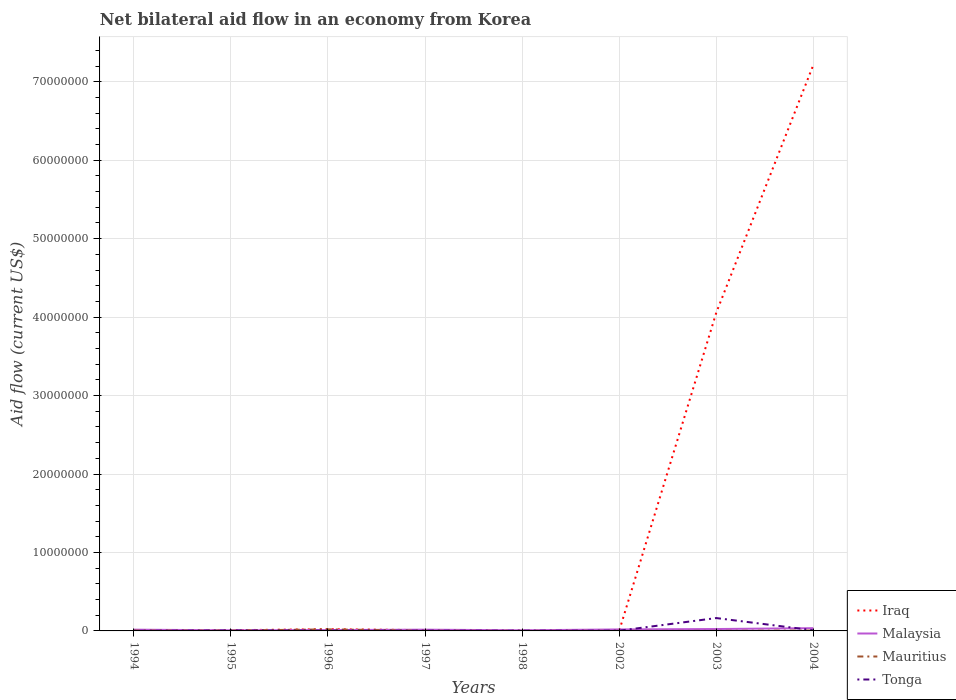How many different coloured lines are there?
Make the answer very short. 4. Does the line corresponding to Mauritius intersect with the line corresponding to Malaysia?
Offer a terse response. Yes. Is the number of lines equal to the number of legend labels?
Keep it short and to the point. Yes. Across all years, what is the maximum net bilateral aid flow in Iraq?
Your answer should be compact. 10000. What is the total net bilateral aid flow in Mauritius in the graph?
Keep it short and to the point. 1.50e+05. What is the difference between the highest and the second highest net bilateral aid flow in Iraq?
Ensure brevity in your answer.  7.21e+07. What is the difference between the highest and the lowest net bilateral aid flow in Iraq?
Your answer should be compact. 2. Is the net bilateral aid flow in Malaysia strictly greater than the net bilateral aid flow in Iraq over the years?
Ensure brevity in your answer.  No. How many years are there in the graph?
Provide a short and direct response. 8. Does the graph contain grids?
Provide a succinct answer. Yes. How many legend labels are there?
Make the answer very short. 4. What is the title of the graph?
Offer a terse response. Net bilateral aid flow in an economy from Korea. What is the label or title of the X-axis?
Your answer should be very brief. Years. What is the Aid flow (current US$) in Malaysia in 1994?
Your response must be concise. 1.60e+05. What is the Aid flow (current US$) in Mauritius in 1994?
Keep it short and to the point. 4.00e+04. What is the Aid flow (current US$) in Tonga in 1994?
Keep it short and to the point. 10000. What is the Aid flow (current US$) in Iraq in 1995?
Provide a short and direct response. 9.00e+04. What is the Aid flow (current US$) of Malaysia in 1995?
Provide a succinct answer. 8.00e+04. What is the Aid flow (current US$) in Mauritius in 1996?
Your response must be concise. 2.00e+05. What is the Aid flow (current US$) in Tonga in 1996?
Make the answer very short. 4.00e+04. What is the Aid flow (current US$) in Iraq in 1997?
Offer a terse response. 1.00e+05. What is the Aid flow (current US$) of Malaysia in 1997?
Provide a short and direct response. 1.60e+05. What is the Aid flow (current US$) of Tonga in 1997?
Your response must be concise. 3.00e+04. What is the Aid flow (current US$) of Mauritius in 1998?
Offer a terse response. 10000. What is the Aid flow (current US$) of Tonga in 1998?
Offer a terse response. 3.00e+04. What is the Aid flow (current US$) of Iraq in 2002?
Ensure brevity in your answer.  10000. What is the Aid flow (current US$) in Mauritius in 2002?
Provide a succinct answer. 10000. What is the Aid flow (current US$) in Tonga in 2002?
Your answer should be very brief. 3.00e+04. What is the Aid flow (current US$) in Iraq in 2003?
Ensure brevity in your answer.  4.06e+07. What is the Aid flow (current US$) in Tonga in 2003?
Make the answer very short. 1.64e+06. What is the Aid flow (current US$) of Iraq in 2004?
Provide a short and direct response. 7.22e+07. What is the Aid flow (current US$) of Malaysia in 2004?
Keep it short and to the point. 3.50e+05. What is the Aid flow (current US$) of Tonga in 2004?
Your answer should be very brief. 8.00e+04. Across all years, what is the maximum Aid flow (current US$) of Iraq?
Ensure brevity in your answer.  7.22e+07. Across all years, what is the maximum Aid flow (current US$) of Malaysia?
Give a very brief answer. 3.50e+05. Across all years, what is the maximum Aid flow (current US$) of Tonga?
Offer a terse response. 1.64e+06. Across all years, what is the minimum Aid flow (current US$) of Iraq?
Provide a succinct answer. 10000. Across all years, what is the minimum Aid flow (current US$) of Tonga?
Your answer should be very brief. 10000. What is the total Aid flow (current US$) in Iraq in the graph?
Keep it short and to the point. 1.13e+08. What is the total Aid flow (current US$) in Malaysia in the graph?
Keep it short and to the point. 1.37e+06. What is the total Aid flow (current US$) of Mauritius in the graph?
Offer a very short reply. 3.80e+05. What is the total Aid flow (current US$) of Tonga in the graph?
Make the answer very short. 1.92e+06. What is the difference between the Aid flow (current US$) of Malaysia in 1994 and that in 1995?
Your answer should be compact. 8.00e+04. What is the difference between the Aid flow (current US$) of Mauritius in 1994 and that in 1995?
Your answer should be compact. 0. What is the difference between the Aid flow (current US$) of Mauritius in 1994 and that in 1996?
Offer a very short reply. -1.60e+05. What is the difference between the Aid flow (current US$) in Tonga in 1994 and that in 1996?
Offer a very short reply. -3.00e+04. What is the difference between the Aid flow (current US$) in Iraq in 1994 and that in 1998?
Offer a terse response. 0. What is the difference between the Aid flow (current US$) in Malaysia in 1994 and that in 1998?
Give a very brief answer. 8.00e+04. What is the difference between the Aid flow (current US$) in Mauritius in 1994 and that in 1998?
Give a very brief answer. 3.00e+04. What is the difference between the Aid flow (current US$) in Mauritius in 1994 and that in 2002?
Make the answer very short. 3.00e+04. What is the difference between the Aid flow (current US$) in Tonga in 1994 and that in 2002?
Offer a terse response. -2.00e+04. What is the difference between the Aid flow (current US$) in Iraq in 1994 and that in 2003?
Ensure brevity in your answer.  -4.06e+07. What is the difference between the Aid flow (current US$) in Malaysia in 1994 and that in 2003?
Provide a succinct answer. -8.00e+04. What is the difference between the Aid flow (current US$) of Tonga in 1994 and that in 2003?
Ensure brevity in your answer.  -1.63e+06. What is the difference between the Aid flow (current US$) of Iraq in 1994 and that in 2004?
Keep it short and to the point. -7.21e+07. What is the difference between the Aid flow (current US$) in Malaysia in 1994 and that in 2004?
Offer a terse response. -1.90e+05. What is the difference between the Aid flow (current US$) of Mauritius in 1995 and that in 1996?
Provide a short and direct response. -1.60e+05. What is the difference between the Aid flow (current US$) in Tonga in 1995 and that in 1996?
Keep it short and to the point. 2.00e+04. What is the difference between the Aid flow (current US$) in Malaysia in 1995 and that in 1997?
Keep it short and to the point. -8.00e+04. What is the difference between the Aid flow (current US$) in Mauritius in 1995 and that in 1998?
Offer a terse response. 3.00e+04. What is the difference between the Aid flow (current US$) in Malaysia in 1995 and that in 2002?
Offer a terse response. -1.10e+05. What is the difference between the Aid flow (current US$) of Tonga in 1995 and that in 2002?
Give a very brief answer. 3.00e+04. What is the difference between the Aid flow (current US$) in Iraq in 1995 and that in 2003?
Provide a succinct answer. -4.05e+07. What is the difference between the Aid flow (current US$) of Tonga in 1995 and that in 2003?
Your answer should be compact. -1.58e+06. What is the difference between the Aid flow (current US$) in Iraq in 1995 and that in 2004?
Your answer should be very brief. -7.21e+07. What is the difference between the Aid flow (current US$) in Malaysia in 1995 and that in 2004?
Ensure brevity in your answer.  -2.70e+05. What is the difference between the Aid flow (current US$) in Iraq in 1996 and that in 1997?
Your response must be concise. 1.20e+05. What is the difference between the Aid flow (current US$) of Malaysia in 1996 and that in 1997?
Offer a very short reply. -5.00e+04. What is the difference between the Aid flow (current US$) in Tonga in 1996 and that in 1997?
Ensure brevity in your answer.  10000. What is the difference between the Aid flow (current US$) in Mauritius in 1996 and that in 1998?
Give a very brief answer. 1.90e+05. What is the difference between the Aid flow (current US$) in Iraq in 1996 and that in 2002?
Your answer should be very brief. 2.10e+05. What is the difference between the Aid flow (current US$) in Mauritius in 1996 and that in 2002?
Your response must be concise. 1.90e+05. What is the difference between the Aid flow (current US$) in Iraq in 1996 and that in 2003?
Provide a succinct answer. -4.04e+07. What is the difference between the Aid flow (current US$) of Mauritius in 1996 and that in 2003?
Your answer should be very brief. 1.90e+05. What is the difference between the Aid flow (current US$) of Tonga in 1996 and that in 2003?
Give a very brief answer. -1.60e+06. What is the difference between the Aid flow (current US$) of Iraq in 1996 and that in 2004?
Keep it short and to the point. -7.19e+07. What is the difference between the Aid flow (current US$) of Iraq in 1997 and that in 1998?
Ensure brevity in your answer.  8.00e+04. What is the difference between the Aid flow (current US$) of Malaysia in 1997 and that in 1998?
Offer a terse response. 8.00e+04. What is the difference between the Aid flow (current US$) in Mauritius in 1997 and that in 1998?
Provide a succinct answer. 10000. What is the difference between the Aid flow (current US$) of Tonga in 1997 and that in 1998?
Keep it short and to the point. 0. What is the difference between the Aid flow (current US$) in Iraq in 1997 and that in 2002?
Ensure brevity in your answer.  9.00e+04. What is the difference between the Aid flow (current US$) of Malaysia in 1997 and that in 2002?
Provide a short and direct response. -3.00e+04. What is the difference between the Aid flow (current US$) in Mauritius in 1997 and that in 2002?
Make the answer very short. 10000. What is the difference between the Aid flow (current US$) of Tonga in 1997 and that in 2002?
Your answer should be very brief. 0. What is the difference between the Aid flow (current US$) of Iraq in 1997 and that in 2003?
Provide a succinct answer. -4.05e+07. What is the difference between the Aid flow (current US$) in Mauritius in 1997 and that in 2003?
Make the answer very short. 10000. What is the difference between the Aid flow (current US$) in Tonga in 1997 and that in 2003?
Keep it short and to the point. -1.61e+06. What is the difference between the Aid flow (current US$) in Iraq in 1997 and that in 2004?
Provide a short and direct response. -7.20e+07. What is the difference between the Aid flow (current US$) of Malaysia in 1997 and that in 2004?
Give a very brief answer. -1.90e+05. What is the difference between the Aid flow (current US$) of Malaysia in 1998 and that in 2002?
Provide a succinct answer. -1.10e+05. What is the difference between the Aid flow (current US$) of Iraq in 1998 and that in 2003?
Keep it short and to the point. -4.06e+07. What is the difference between the Aid flow (current US$) of Tonga in 1998 and that in 2003?
Your answer should be compact. -1.61e+06. What is the difference between the Aid flow (current US$) of Iraq in 1998 and that in 2004?
Offer a very short reply. -7.21e+07. What is the difference between the Aid flow (current US$) of Malaysia in 1998 and that in 2004?
Ensure brevity in your answer.  -2.70e+05. What is the difference between the Aid flow (current US$) in Iraq in 2002 and that in 2003?
Offer a terse response. -4.06e+07. What is the difference between the Aid flow (current US$) in Malaysia in 2002 and that in 2003?
Ensure brevity in your answer.  -5.00e+04. What is the difference between the Aid flow (current US$) of Mauritius in 2002 and that in 2003?
Offer a very short reply. 0. What is the difference between the Aid flow (current US$) of Tonga in 2002 and that in 2003?
Ensure brevity in your answer.  -1.61e+06. What is the difference between the Aid flow (current US$) in Iraq in 2002 and that in 2004?
Keep it short and to the point. -7.21e+07. What is the difference between the Aid flow (current US$) in Mauritius in 2002 and that in 2004?
Provide a short and direct response. -4.00e+04. What is the difference between the Aid flow (current US$) in Tonga in 2002 and that in 2004?
Give a very brief answer. -5.00e+04. What is the difference between the Aid flow (current US$) of Iraq in 2003 and that in 2004?
Ensure brevity in your answer.  -3.16e+07. What is the difference between the Aid flow (current US$) of Tonga in 2003 and that in 2004?
Offer a terse response. 1.56e+06. What is the difference between the Aid flow (current US$) of Iraq in 1994 and the Aid flow (current US$) of Malaysia in 1995?
Provide a succinct answer. -6.00e+04. What is the difference between the Aid flow (current US$) in Iraq in 1994 and the Aid flow (current US$) in Mauritius in 1995?
Give a very brief answer. -2.00e+04. What is the difference between the Aid flow (current US$) of Malaysia in 1994 and the Aid flow (current US$) of Mauritius in 1995?
Offer a terse response. 1.20e+05. What is the difference between the Aid flow (current US$) of Malaysia in 1994 and the Aid flow (current US$) of Tonga in 1995?
Make the answer very short. 1.00e+05. What is the difference between the Aid flow (current US$) of Mauritius in 1994 and the Aid flow (current US$) of Tonga in 1995?
Your answer should be very brief. -2.00e+04. What is the difference between the Aid flow (current US$) in Iraq in 1994 and the Aid flow (current US$) in Malaysia in 1996?
Give a very brief answer. -9.00e+04. What is the difference between the Aid flow (current US$) in Iraq in 1994 and the Aid flow (current US$) in Mauritius in 1996?
Give a very brief answer. -1.80e+05. What is the difference between the Aid flow (current US$) of Malaysia in 1994 and the Aid flow (current US$) of Mauritius in 1996?
Your answer should be compact. -4.00e+04. What is the difference between the Aid flow (current US$) of Mauritius in 1994 and the Aid flow (current US$) of Tonga in 1996?
Make the answer very short. 0. What is the difference between the Aid flow (current US$) of Iraq in 1994 and the Aid flow (current US$) of Mauritius in 1997?
Provide a succinct answer. 0. What is the difference between the Aid flow (current US$) in Iraq in 1994 and the Aid flow (current US$) in Tonga in 1997?
Your answer should be very brief. -10000. What is the difference between the Aid flow (current US$) of Malaysia in 1994 and the Aid flow (current US$) of Mauritius in 1997?
Provide a succinct answer. 1.40e+05. What is the difference between the Aid flow (current US$) of Malaysia in 1994 and the Aid flow (current US$) of Tonga in 1997?
Provide a short and direct response. 1.30e+05. What is the difference between the Aid flow (current US$) in Mauritius in 1994 and the Aid flow (current US$) in Tonga in 1997?
Your answer should be compact. 10000. What is the difference between the Aid flow (current US$) of Iraq in 1994 and the Aid flow (current US$) of Tonga in 1998?
Provide a short and direct response. -10000. What is the difference between the Aid flow (current US$) in Malaysia in 1994 and the Aid flow (current US$) in Mauritius in 1998?
Provide a succinct answer. 1.50e+05. What is the difference between the Aid flow (current US$) in Iraq in 1994 and the Aid flow (current US$) in Malaysia in 2002?
Ensure brevity in your answer.  -1.70e+05. What is the difference between the Aid flow (current US$) in Iraq in 1994 and the Aid flow (current US$) in Mauritius in 2002?
Offer a terse response. 10000. What is the difference between the Aid flow (current US$) in Mauritius in 1994 and the Aid flow (current US$) in Tonga in 2002?
Offer a terse response. 10000. What is the difference between the Aid flow (current US$) in Iraq in 1994 and the Aid flow (current US$) in Malaysia in 2003?
Your response must be concise. -2.20e+05. What is the difference between the Aid flow (current US$) of Iraq in 1994 and the Aid flow (current US$) of Mauritius in 2003?
Your response must be concise. 10000. What is the difference between the Aid flow (current US$) in Iraq in 1994 and the Aid flow (current US$) in Tonga in 2003?
Provide a succinct answer. -1.62e+06. What is the difference between the Aid flow (current US$) in Malaysia in 1994 and the Aid flow (current US$) in Mauritius in 2003?
Your response must be concise. 1.50e+05. What is the difference between the Aid flow (current US$) in Malaysia in 1994 and the Aid flow (current US$) in Tonga in 2003?
Offer a very short reply. -1.48e+06. What is the difference between the Aid flow (current US$) of Mauritius in 1994 and the Aid flow (current US$) of Tonga in 2003?
Give a very brief answer. -1.60e+06. What is the difference between the Aid flow (current US$) in Iraq in 1994 and the Aid flow (current US$) in Malaysia in 2004?
Offer a very short reply. -3.30e+05. What is the difference between the Aid flow (current US$) of Iraq in 1994 and the Aid flow (current US$) of Tonga in 2004?
Offer a very short reply. -6.00e+04. What is the difference between the Aid flow (current US$) of Malaysia in 1994 and the Aid flow (current US$) of Tonga in 2004?
Offer a terse response. 8.00e+04. What is the difference between the Aid flow (current US$) in Mauritius in 1994 and the Aid flow (current US$) in Tonga in 2004?
Offer a very short reply. -4.00e+04. What is the difference between the Aid flow (current US$) of Iraq in 1995 and the Aid flow (current US$) of Tonga in 1996?
Give a very brief answer. 5.00e+04. What is the difference between the Aid flow (current US$) in Iraq in 1995 and the Aid flow (current US$) in Tonga in 1997?
Keep it short and to the point. 6.00e+04. What is the difference between the Aid flow (current US$) in Malaysia in 1995 and the Aid flow (current US$) in Mauritius in 1997?
Provide a succinct answer. 6.00e+04. What is the difference between the Aid flow (current US$) of Malaysia in 1995 and the Aid flow (current US$) of Tonga in 1997?
Provide a short and direct response. 5.00e+04. What is the difference between the Aid flow (current US$) in Mauritius in 1995 and the Aid flow (current US$) in Tonga in 1997?
Offer a terse response. 10000. What is the difference between the Aid flow (current US$) of Iraq in 1995 and the Aid flow (current US$) of Malaysia in 1998?
Ensure brevity in your answer.  10000. What is the difference between the Aid flow (current US$) in Iraq in 1995 and the Aid flow (current US$) in Mauritius in 1998?
Your response must be concise. 8.00e+04. What is the difference between the Aid flow (current US$) of Iraq in 1995 and the Aid flow (current US$) of Tonga in 1998?
Make the answer very short. 6.00e+04. What is the difference between the Aid flow (current US$) of Malaysia in 1995 and the Aid flow (current US$) of Mauritius in 1998?
Provide a short and direct response. 7.00e+04. What is the difference between the Aid flow (current US$) in Iraq in 1995 and the Aid flow (current US$) in Malaysia in 2002?
Give a very brief answer. -1.00e+05. What is the difference between the Aid flow (current US$) of Iraq in 1995 and the Aid flow (current US$) of Mauritius in 2002?
Your answer should be compact. 8.00e+04. What is the difference between the Aid flow (current US$) of Iraq in 1995 and the Aid flow (current US$) of Tonga in 2002?
Provide a short and direct response. 6.00e+04. What is the difference between the Aid flow (current US$) of Iraq in 1995 and the Aid flow (current US$) of Malaysia in 2003?
Provide a short and direct response. -1.50e+05. What is the difference between the Aid flow (current US$) in Iraq in 1995 and the Aid flow (current US$) in Tonga in 2003?
Your answer should be compact. -1.55e+06. What is the difference between the Aid flow (current US$) in Malaysia in 1995 and the Aid flow (current US$) in Mauritius in 2003?
Ensure brevity in your answer.  7.00e+04. What is the difference between the Aid flow (current US$) in Malaysia in 1995 and the Aid flow (current US$) in Tonga in 2003?
Your answer should be compact. -1.56e+06. What is the difference between the Aid flow (current US$) in Mauritius in 1995 and the Aid flow (current US$) in Tonga in 2003?
Ensure brevity in your answer.  -1.60e+06. What is the difference between the Aid flow (current US$) in Iraq in 1995 and the Aid flow (current US$) in Malaysia in 2004?
Offer a terse response. -2.60e+05. What is the difference between the Aid flow (current US$) of Malaysia in 1995 and the Aid flow (current US$) of Tonga in 2004?
Your answer should be very brief. 0. What is the difference between the Aid flow (current US$) in Mauritius in 1995 and the Aid flow (current US$) in Tonga in 2004?
Offer a very short reply. -4.00e+04. What is the difference between the Aid flow (current US$) of Iraq in 1996 and the Aid flow (current US$) of Tonga in 1997?
Provide a short and direct response. 1.90e+05. What is the difference between the Aid flow (current US$) of Malaysia in 1996 and the Aid flow (current US$) of Mauritius in 1997?
Offer a very short reply. 9.00e+04. What is the difference between the Aid flow (current US$) in Malaysia in 1996 and the Aid flow (current US$) in Tonga in 1997?
Your answer should be very brief. 8.00e+04. What is the difference between the Aid flow (current US$) of Mauritius in 1996 and the Aid flow (current US$) of Tonga in 1997?
Offer a very short reply. 1.70e+05. What is the difference between the Aid flow (current US$) in Iraq in 1996 and the Aid flow (current US$) in Mauritius in 1998?
Ensure brevity in your answer.  2.10e+05. What is the difference between the Aid flow (current US$) of Iraq in 1996 and the Aid flow (current US$) of Tonga in 1998?
Your response must be concise. 1.90e+05. What is the difference between the Aid flow (current US$) in Malaysia in 1996 and the Aid flow (current US$) in Mauritius in 1998?
Offer a terse response. 1.00e+05. What is the difference between the Aid flow (current US$) in Iraq in 1996 and the Aid flow (current US$) in Malaysia in 2002?
Provide a short and direct response. 3.00e+04. What is the difference between the Aid flow (current US$) in Iraq in 1996 and the Aid flow (current US$) in Mauritius in 2002?
Make the answer very short. 2.10e+05. What is the difference between the Aid flow (current US$) of Malaysia in 1996 and the Aid flow (current US$) of Mauritius in 2002?
Ensure brevity in your answer.  1.00e+05. What is the difference between the Aid flow (current US$) in Iraq in 1996 and the Aid flow (current US$) in Malaysia in 2003?
Your answer should be compact. -2.00e+04. What is the difference between the Aid flow (current US$) in Iraq in 1996 and the Aid flow (current US$) in Tonga in 2003?
Keep it short and to the point. -1.42e+06. What is the difference between the Aid flow (current US$) of Malaysia in 1996 and the Aid flow (current US$) of Tonga in 2003?
Make the answer very short. -1.53e+06. What is the difference between the Aid flow (current US$) of Mauritius in 1996 and the Aid flow (current US$) of Tonga in 2003?
Your response must be concise. -1.44e+06. What is the difference between the Aid flow (current US$) in Iraq in 1996 and the Aid flow (current US$) in Malaysia in 2004?
Offer a terse response. -1.30e+05. What is the difference between the Aid flow (current US$) in Iraq in 1996 and the Aid flow (current US$) in Mauritius in 2004?
Provide a succinct answer. 1.70e+05. What is the difference between the Aid flow (current US$) of Iraq in 1997 and the Aid flow (current US$) of Tonga in 1998?
Your response must be concise. 7.00e+04. What is the difference between the Aid flow (current US$) in Mauritius in 1997 and the Aid flow (current US$) in Tonga in 1998?
Provide a succinct answer. -10000. What is the difference between the Aid flow (current US$) of Iraq in 1997 and the Aid flow (current US$) of Malaysia in 2002?
Provide a short and direct response. -9.00e+04. What is the difference between the Aid flow (current US$) of Malaysia in 1997 and the Aid flow (current US$) of Mauritius in 2002?
Your answer should be very brief. 1.50e+05. What is the difference between the Aid flow (current US$) of Malaysia in 1997 and the Aid flow (current US$) of Tonga in 2002?
Provide a succinct answer. 1.30e+05. What is the difference between the Aid flow (current US$) of Iraq in 1997 and the Aid flow (current US$) of Malaysia in 2003?
Provide a succinct answer. -1.40e+05. What is the difference between the Aid flow (current US$) of Iraq in 1997 and the Aid flow (current US$) of Tonga in 2003?
Give a very brief answer. -1.54e+06. What is the difference between the Aid flow (current US$) of Malaysia in 1997 and the Aid flow (current US$) of Tonga in 2003?
Provide a succinct answer. -1.48e+06. What is the difference between the Aid flow (current US$) of Mauritius in 1997 and the Aid flow (current US$) of Tonga in 2003?
Offer a terse response. -1.62e+06. What is the difference between the Aid flow (current US$) in Iraq in 1997 and the Aid flow (current US$) in Malaysia in 2004?
Your answer should be very brief. -2.50e+05. What is the difference between the Aid flow (current US$) of Iraq in 1997 and the Aid flow (current US$) of Tonga in 2004?
Offer a terse response. 2.00e+04. What is the difference between the Aid flow (current US$) in Malaysia in 1997 and the Aid flow (current US$) in Mauritius in 2004?
Ensure brevity in your answer.  1.10e+05. What is the difference between the Aid flow (current US$) in Iraq in 1998 and the Aid flow (current US$) in Malaysia in 2002?
Give a very brief answer. -1.70e+05. What is the difference between the Aid flow (current US$) in Iraq in 1998 and the Aid flow (current US$) in Malaysia in 2003?
Keep it short and to the point. -2.20e+05. What is the difference between the Aid flow (current US$) in Iraq in 1998 and the Aid flow (current US$) in Mauritius in 2003?
Your answer should be compact. 10000. What is the difference between the Aid flow (current US$) of Iraq in 1998 and the Aid flow (current US$) of Tonga in 2003?
Give a very brief answer. -1.62e+06. What is the difference between the Aid flow (current US$) in Malaysia in 1998 and the Aid flow (current US$) in Tonga in 2003?
Make the answer very short. -1.56e+06. What is the difference between the Aid flow (current US$) in Mauritius in 1998 and the Aid flow (current US$) in Tonga in 2003?
Provide a succinct answer. -1.63e+06. What is the difference between the Aid flow (current US$) in Iraq in 1998 and the Aid flow (current US$) in Malaysia in 2004?
Offer a very short reply. -3.30e+05. What is the difference between the Aid flow (current US$) in Iraq in 1998 and the Aid flow (current US$) in Mauritius in 2004?
Provide a short and direct response. -3.00e+04. What is the difference between the Aid flow (current US$) of Iraq in 1998 and the Aid flow (current US$) of Tonga in 2004?
Keep it short and to the point. -6.00e+04. What is the difference between the Aid flow (current US$) of Malaysia in 1998 and the Aid flow (current US$) of Mauritius in 2004?
Your answer should be very brief. 3.00e+04. What is the difference between the Aid flow (current US$) in Iraq in 2002 and the Aid flow (current US$) in Malaysia in 2003?
Your response must be concise. -2.30e+05. What is the difference between the Aid flow (current US$) in Iraq in 2002 and the Aid flow (current US$) in Tonga in 2003?
Your answer should be very brief. -1.63e+06. What is the difference between the Aid flow (current US$) of Malaysia in 2002 and the Aid flow (current US$) of Mauritius in 2003?
Make the answer very short. 1.80e+05. What is the difference between the Aid flow (current US$) in Malaysia in 2002 and the Aid flow (current US$) in Tonga in 2003?
Your answer should be compact. -1.45e+06. What is the difference between the Aid flow (current US$) of Mauritius in 2002 and the Aid flow (current US$) of Tonga in 2003?
Ensure brevity in your answer.  -1.63e+06. What is the difference between the Aid flow (current US$) of Malaysia in 2002 and the Aid flow (current US$) of Mauritius in 2004?
Give a very brief answer. 1.40e+05. What is the difference between the Aid flow (current US$) in Malaysia in 2002 and the Aid flow (current US$) in Tonga in 2004?
Give a very brief answer. 1.10e+05. What is the difference between the Aid flow (current US$) of Mauritius in 2002 and the Aid flow (current US$) of Tonga in 2004?
Give a very brief answer. -7.00e+04. What is the difference between the Aid flow (current US$) of Iraq in 2003 and the Aid flow (current US$) of Malaysia in 2004?
Ensure brevity in your answer.  4.02e+07. What is the difference between the Aid flow (current US$) in Iraq in 2003 and the Aid flow (current US$) in Mauritius in 2004?
Provide a succinct answer. 4.05e+07. What is the difference between the Aid flow (current US$) in Iraq in 2003 and the Aid flow (current US$) in Tonga in 2004?
Make the answer very short. 4.05e+07. What is the difference between the Aid flow (current US$) of Malaysia in 2003 and the Aid flow (current US$) of Mauritius in 2004?
Provide a succinct answer. 1.90e+05. What is the average Aid flow (current US$) of Iraq per year?
Give a very brief answer. 1.41e+07. What is the average Aid flow (current US$) of Malaysia per year?
Keep it short and to the point. 1.71e+05. What is the average Aid flow (current US$) in Mauritius per year?
Your answer should be very brief. 4.75e+04. In the year 1994, what is the difference between the Aid flow (current US$) in Iraq and Aid flow (current US$) in Mauritius?
Ensure brevity in your answer.  -2.00e+04. In the year 1994, what is the difference between the Aid flow (current US$) in Iraq and Aid flow (current US$) in Tonga?
Provide a short and direct response. 10000. In the year 1994, what is the difference between the Aid flow (current US$) of Mauritius and Aid flow (current US$) of Tonga?
Your answer should be very brief. 3.00e+04. In the year 1995, what is the difference between the Aid flow (current US$) of Iraq and Aid flow (current US$) of Mauritius?
Your answer should be compact. 5.00e+04. In the year 1995, what is the difference between the Aid flow (current US$) in Malaysia and Aid flow (current US$) in Mauritius?
Your answer should be very brief. 4.00e+04. In the year 1996, what is the difference between the Aid flow (current US$) in Iraq and Aid flow (current US$) in Malaysia?
Offer a very short reply. 1.10e+05. In the year 1996, what is the difference between the Aid flow (current US$) of Iraq and Aid flow (current US$) of Mauritius?
Offer a very short reply. 2.00e+04. In the year 1996, what is the difference between the Aid flow (current US$) in Iraq and Aid flow (current US$) in Tonga?
Your response must be concise. 1.80e+05. In the year 1996, what is the difference between the Aid flow (current US$) in Malaysia and Aid flow (current US$) in Mauritius?
Your answer should be compact. -9.00e+04. In the year 1996, what is the difference between the Aid flow (current US$) of Mauritius and Aid flow (current US$) of Tonga?
Your response must be concise. 1.60e+05. In the year 1997, what is the difference between the Aid flow (current US$) of Iraq and Aid flow (current US$) of Malaysia?
Give a very brief answer. -6.00e+04. In the year 1997, what is the difference between the Aid flow (current US$) in Iraq and Aid flow (current US$) in Mauritius?
Make the answer very short. 8.00e+04. In the year 1998, what is the difference between the Aid flow (current US$) in Iraq and Aid flow (current US$) in Mauritius?
Make the answer very short. 10000. In the year 1998, what is the difference between the Aid flow (current US$) of Iraq and Aid flow (current US$) of Tonga?
Offer a terse response. -10000. In the year 1998, what is the difference between the Aid flow (current US$) in Malaysia and Aid flow (current US$) in Mauritius?
Provide a succinct answer. 7.00e+04. In the year 1998, what is the difference between the Aid flow (current US$) of Mauritius and Aid flow (current US$) of Tonga?
Ensure brevity in your answer.  -2.00e+04. In the year 2002, what is the difference between the Aid flow (current US$) in Iraq and Aid flow (current US$) in Malaysia?
Offer a very short reply. -1.80e+05. In the year 2002, what is the difference between the Aid flow (current US$) in Iraq and Aid flow (current US$) in Mauritius?
Your answer should be very brief. 0. In the year 2002, what is the difference between the Aid flow (current US$) in Malaysia and Aid flow (current US$) in Tonga?
Give a very brief answer. 1.60e+05. In the year 2003, what is the difference between the Aid flow (current US$) of Iraq and Aid flow (current US$) of Malaysia?
Your answer should be very brief. 4.03e+07. In the year 2003, what is the difference between the Aid flow (current US$) in Iraq and Aid flow (current US$) in Mauritius?
Provide a short and direct response. 4.06e+07. In the year 2003, what is the difference between the Aid flow (current US$) in Iraq and Aid flow (current US$) in Tonga?
Give a very brief answer. 3.89e+07. In the year 2003, what is the difference between the Aid flow (current US$) of Malaysia and Aid flow (current US$) of Tonga?
Keep it short and to the point. -1.40e+06. In the year 2003, what is the difference between the Aid flow (current US$) in Mauritius and Aid flow (current US$) in Tonga?
Keep it short and to the point. -1.63e+06. In the year 2004, what is the difference between the Aid flow (current US$) in Iraq and Aid flow (current US$) in Malaysia?
Make the answer very short. 7.18e+07. In the year 2004, what is the difference between the Aid flow (current US$) of Iraq and Aid flow (current US$) of Mauritius?
Offer a very short reply. 7.21e+07. In the year 2004, what is the difference between the Aid flow (current US$) of Iraq and Aid flow (current US$) of Tonga?
Provide a succinct answer. 7.21e+07. In the year 2004, what is the difference between the Aid flow (current US$) in Malaysia and Aid flow (current US$) in Tonga?
Provide a short and direct response. 2.70e+05. What is the ratio of the Aid flow (current US$) in Iraq in 1994 to that in 1995?
Give a very brief answer. 0.22. What is the ratio of the Aid flow (current US$) in Malaysia in 1994 to that in 1995?
Provide a succinct answer. 2. What is the ratio of the Aid flow (current US$) of Mauritius in 1994 to that in 1995?
Your answer should be very brief. 1. What is the ratio of the Aid flow (current US$) in Iraq in 1994 to that in 1996?
Your answer should be compact. 0.09. What is the ratio of the Aid flow (current US$) in Malaysia in 1994 to that in 1996?
Ensure brevity in your answer.  1.45. What is the ratio of the Aid flow (current US$) of Tonga in 1994 to that in 1996?
Give a very brief answer. 0.25. What is the ratio of the Aid flow (current US$) in Iraq in 1994 to that in 1997?
Provide a succinct answer. 0.2. What is the ratio of the Aid flow (current US$) in Mauritius in 1994 to that in 1997?
Your answer should be very brief. 2. What is the ratio of the Aid flow (current US$) of Tonga in 1994 to that in 1997?
Your response must be concise. 0.33. What is the ratio of the Aid flow (current US$) of Iraq in 1994 to that in 2002?
Keep it short and to the point. 2. What is the ratio of the Aid flow (current US$) in Malaysia in 1994 to that in 2002?
Offer a terse response. 0.84. What is the ratio of the Aid flow (current US$) in Iraq in 1994 to that in 2003?
Give a very brief answer. 0. What is the ratio of the Aid flow (current US$) in Tonga in 1994 to that in 2003?
Ensure brevity in your answer.  0.01. What is the ratio of the Aid flow (current US$) in Malaysia in 1994 to that in 2004?
Ensure brevity in your answer.  0.46. What is the ratio of the Aid flow (current US$) of Mauritius in 1994 to that in 2004?
Keep it short and to the point. 0.8. What is the ratio of the Aid flow (current US$) of Tonga in 1994 to that in 2004?
Offer a very short reply. 0.12. What is the ratio of the Aid flow (current US$) of Iraq in 1995 to that in 1996?
Your answer should be compact. 0.41. What is the ratio of the Aid flow (current US$) in Malaysia in 1995 to that in 1996?
Your answer should be compact. 0.73. What is the ratio of the Aid flow (current US$) of Iraq in 1995 to that in 1997?
Your answer should be very brief. 0.9. What is the ratio of the Aid flow (current US$) in Malaysia in 1995 to that in 1997?
Make the answer very short. 0.5. What is the ratio of the Aid flow (current US$) of Mauritius in 1995 to that in 1997?
Keep it short and to the point. 2. What is the ratio of the Aid flow (current US$) in Tonga in 1995 to that in 1997?
Keep it short and to the point. 2. What is the ratio of the Aid flow (current US$) in Malaysia in 1995 to that in 1998?
Offer a terse response. 1. What is the ratio of the Aid flow (current US$) of Mauritius in 1995 to that in 1998?
Make the answer very short. 4. What is the ratio of the Aid flow (current US$) of Malaysia in 1995 to that in 2002?
Provide a short and direct response. 0.42. What is the ratio of the Aid flow (current US$) of Iraq in 1995 to that in 2003?
Make the answer very short. 0. What is the ratio of the Aid flow (current US$) of Malaysia in 1995 to that in 2003?
Provide a succinct answer. 0.33. What is the ratio of the Aid flow (current US$) of Mauritius in 1995 to that in 2003?
Your answer should be very brief. 4. What is the ratio of the Aid flow (current US$) of Tonga in 1995 to that in 2003?
Your response must be concise. 0.04. What is the ratio of the Aid flow (current US$) of Iraq in 1995 to that in 2004?
Your answer should be very brief. 0. What is the ratio of the Aid flow (current US$) of Malaysia in 1995 to that in 2004?
Keep it short and to the point. 0.23. What is the ratio of the Aid flow (current US$) of Mauritius in 1995 to that in 2004?
Keep it short and to the point. 0.8. What is the ratio of the Aid flow (current US$) of Iraq in 1996 to that in 1997?
Provide a short and direct response. 2.2. What is the ratio of the Aid flow (current US$) in Malaysia in 1996 to that in 1997?
Provide a succinct answer. 0.69. What is the ratio of the Aid flow (current US$) in Tonga in 1996 to that in 1997?
Ensure brevity in your answer.  1.33. What is the ratio of the Aid flow (current US$) in Malaysia in 1996 to that in 1998?
Ensure brevity in your answer.  1.38. What is the ratio of the Aid flow (current US$) in Mauritius in 1996 to that in 1998?
Your answer should be compact. 20. What is the ratio of the Aid flow (current US$) of Tonga in 1996 to that in 1998?
Offer a very short reply. 1.33. What is the ratio of the Aid flow (current US$) in Iraq in 1996 to that in 2002?
Provide a short and direct response. 22. What is the ratio of the Aid flow (current US$) of Malaysia in 1996 to that in 2002?
Your response must be concise. 0.58. What is the ratio of the Aid flow (current US$) of Iraq in 1996 to that in 2003?
Your answer should be compact. 0.01. What is the ratio of the Aid flow (current US$) in Malaysia in 1996 to that in 2003?
Ensure brevity in your answer.  0.46. What is the ratio of the Aid flow (current US$) of Tonga in 1996 to that in 2003?
Your answer should be compact. 0.02. What is the ratio of the Aid flow (current US$) of Iraq in 1996 to that in 2004?
Your answer should be compact. 0. What is the ratio of the Aid flow (current US$) in Malaysia in 1996 to that in 2004?
Your answer should be very brief. 0.31. What is the ratio of the Aid flow (current US$) of Iraq in 1997 to that in 1998?
Make the answer very short. 5. What is the ratio of the Aid flow (current US$) in Malaysia in 1997 to that in 1998?
Ensure brevity in your answer.  2. What is the ratio of the Aid flow (current US$) in Malaysia in 1997 to that in 2002?
Give a very brief answer. 0.84. What is the ratio of the Aid flow (current US$) in Iraq in 1997 to that in 2003?
Offer a very short reply. 0. What is the ratio of the Aid flow (current US$) of Malaysia in 1997 to that in 2003?
Offer a very short reply. 0.67. What is the ratio of the Aid flow (current US$) of Mauritius in 1997 to that in 2003?
Ensure brevity in your answer.  2. What is the ratio of the Aid flow (current US$) in Tonga in 1997 to that in 2003?
Offer a very short reply. 0.02. What is the ratio of the Aid flow (current US$) of Iraq in 1997 to that in 2004?
Provide a short and direct response. 0. What is the ratio of the Aid flow (current US$) of Malaysia in 1997 to that in 2004?
Ensure brevity in your answer.  0.46. What is the ratio of the Aid flow (current US$) in Tonga in 1997 to that in 2004?
Provide a short and direct response. 0.38. What is the ratio of the Aid flow (current US$) in Iraq in 1998 to that in 2002?
Give a very brief answer. 2. What is the ratio of the Aid flow (current US$) in Malaysia in 1998 to that in 2002?
Offer a very short reply. 0.42. What is the ratio of the Aid flow (current US$) in Tonga in 1998 to that in 2002?
Offer a terse response. 1. What is the ratio of the Aid flow (current US$) in Iraq in 1998 to that in 2003?
Provide a succinct answer. 0. What is the ratio of the Aid flow (current US$) of Malaysia in 1998 to that in 2003?
Provide a short and direct response. 0.33. What is the ratio of the Aid flow (current US$) in Mauritius in 1998 to that in 2003?
Provide a succinct answer. 1. What is the ratio of the Aid flow (current US$) of Tonga in 1998 to that in 2003?
Make the answer very short. 0.02. What is the ratio of the Aid flow (current US$) in Malaysia in 1998 to that in 2004?
Make the answer very short. 0.23. What is the ratio of the Aid flow (current US$) in Mauritius in 1998 to that in 2004?
Offer a terse response. 0.2. What is the ratio of the Aid flow (current US$) of Tonga in 1998 to that in 2004?
Give a very brief answer. 0.38. What is the ratio of the Aid flow (current US$) of Malaysia in 2002 to that in 2003?
Provide a succinct answer. 0.79. What is the ratio of the Aid flow (current US$) in Tonga in 2002 to that in 2003?
Ensure brevity in your answer.  0.02. What is the ratio of the Aid flow (current US$) of Malaysia in 2002 to that in 2004?
Provide a succinct answer. 0.54. What is the ratio of the Aid flow (current US$) of Tonga in 2002 to that in 2004?
Offer a terse response. 0.38. What is the ratio of the Aid flow (current US$) of Iraq in 2003 to that in 2004?
Provide a succinct answer. 0.56. What is the ratio of the Aid flow (current US$) of Malaysia in 2003 to that in 2004?
Make the answer very short. 0.69. What is the ratio of the Aid flow (current US$) of Mauritius in 2003 to that in 2004?
Give a very brief answer. 0.2. What is the ratio of the Aid flow (current US$) of Tonga in 2003 to that in 2004?
Your answer should be very brief. 20.5. What is the difference between the highest and the second highest Aid flow (current US$) in Iraq?
Keep it short and to the point. 3.16e+07. What is the difference between the highest and the second highest Aid flow (current US$) in Tonga?
Offer a terse response. 1.56e+06. What is the difference between the highest and the lowest Aid flow (current US$) of Iraq?
Provide a succinct answer. 7.21e+07. What is the difference between the highest and the lowest Aid flow (current US$) of Malaysia?
Your answer should be compact. 2.70e+05. What is the difference between the highest and the lowest Aid flow (current US$) in Mauritius?
Ensure brevity in your answer.  1.90e+05. What is the difference between the highest and the lowest Aid flow (current US$) in Tonga?
Ensure brevity in your answer.  1.63e+06. 